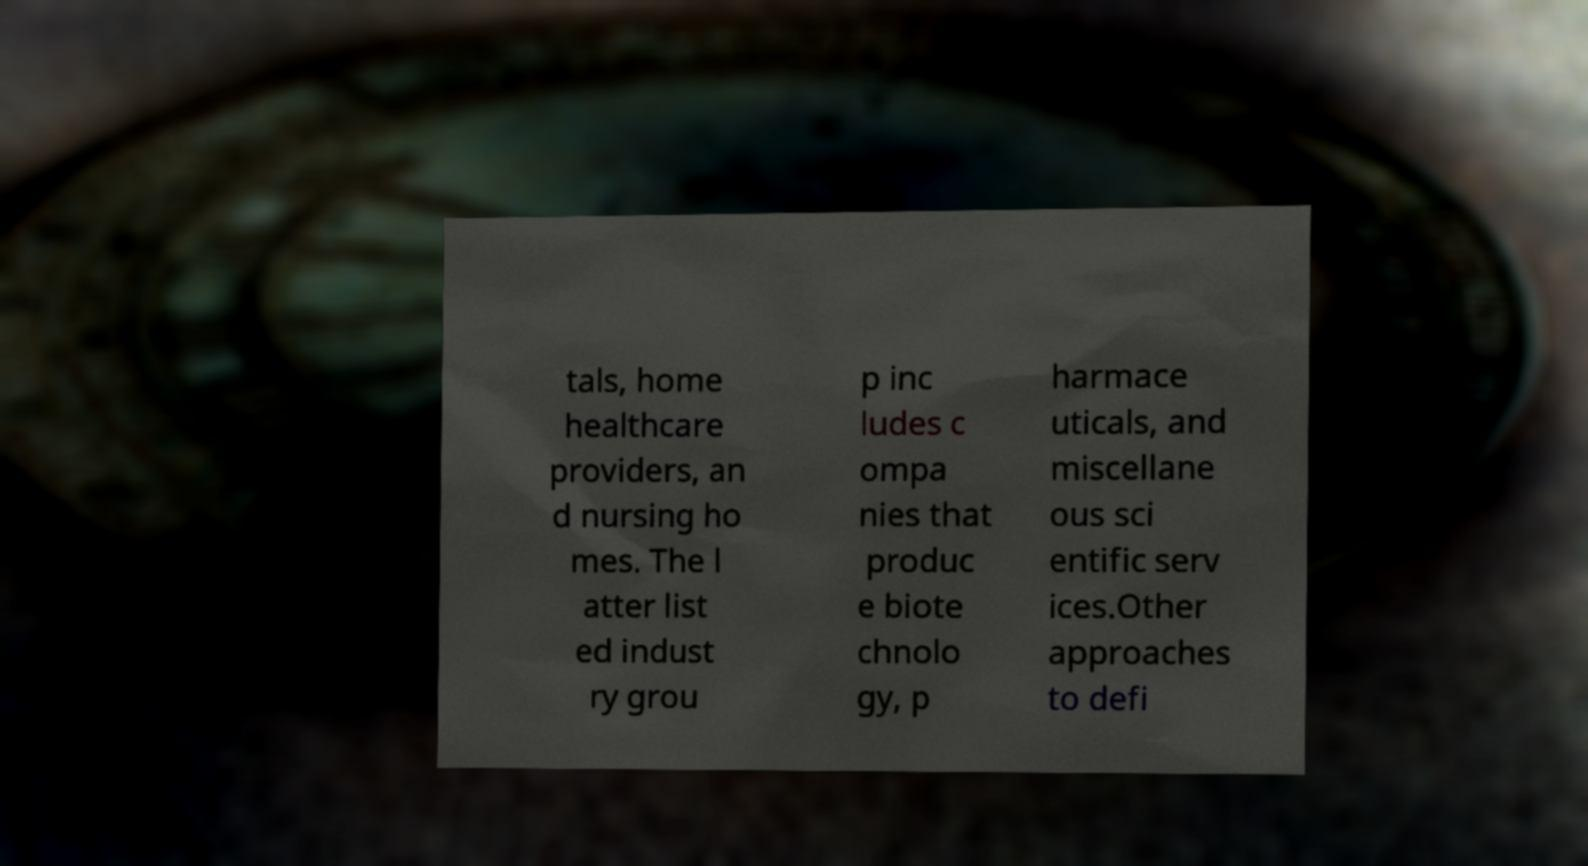Please read and relay the text visible in this image. What does it say? tals, home healthcare providers, an d nursing ho mes. The l atter list ed indust ry grou p inc ludes c ompa nies that produc e biote chnolo gy, p harmace uticals, and miscellane ous sci entific serv ices.Other approaches to defi 